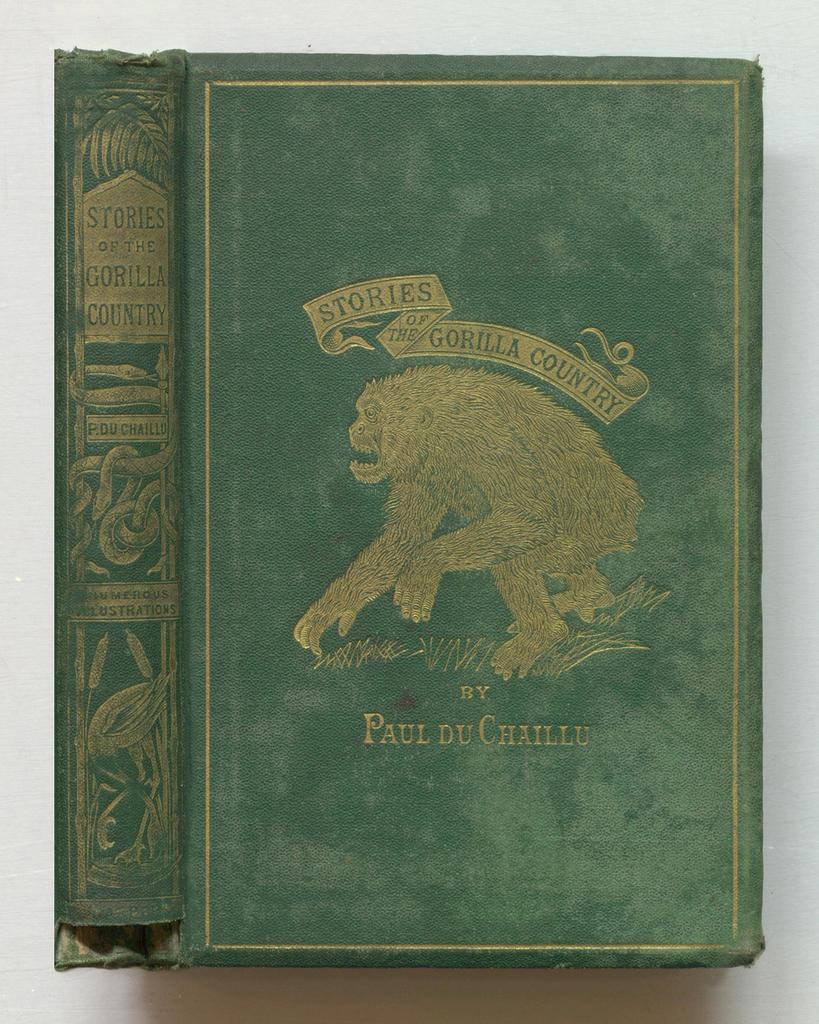Provide a one-sentence caption for the provided image. A green book with a gorilla on the front called "Stories of The Gorilla Country". 